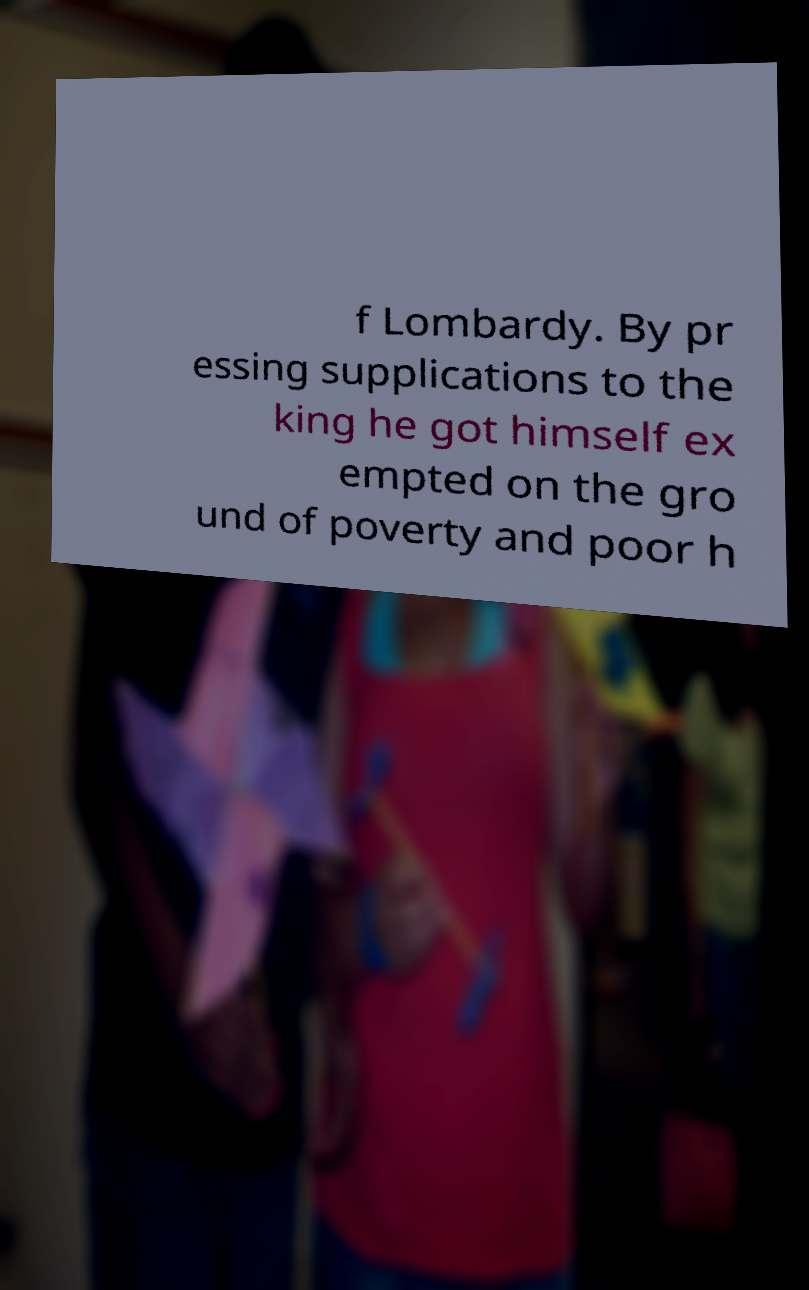I need the written content from this picture converted into text. Can you do that? f Lombardy. By pr essing supplications to the king he got himself ex empted on the gro und of poverty and poor h 